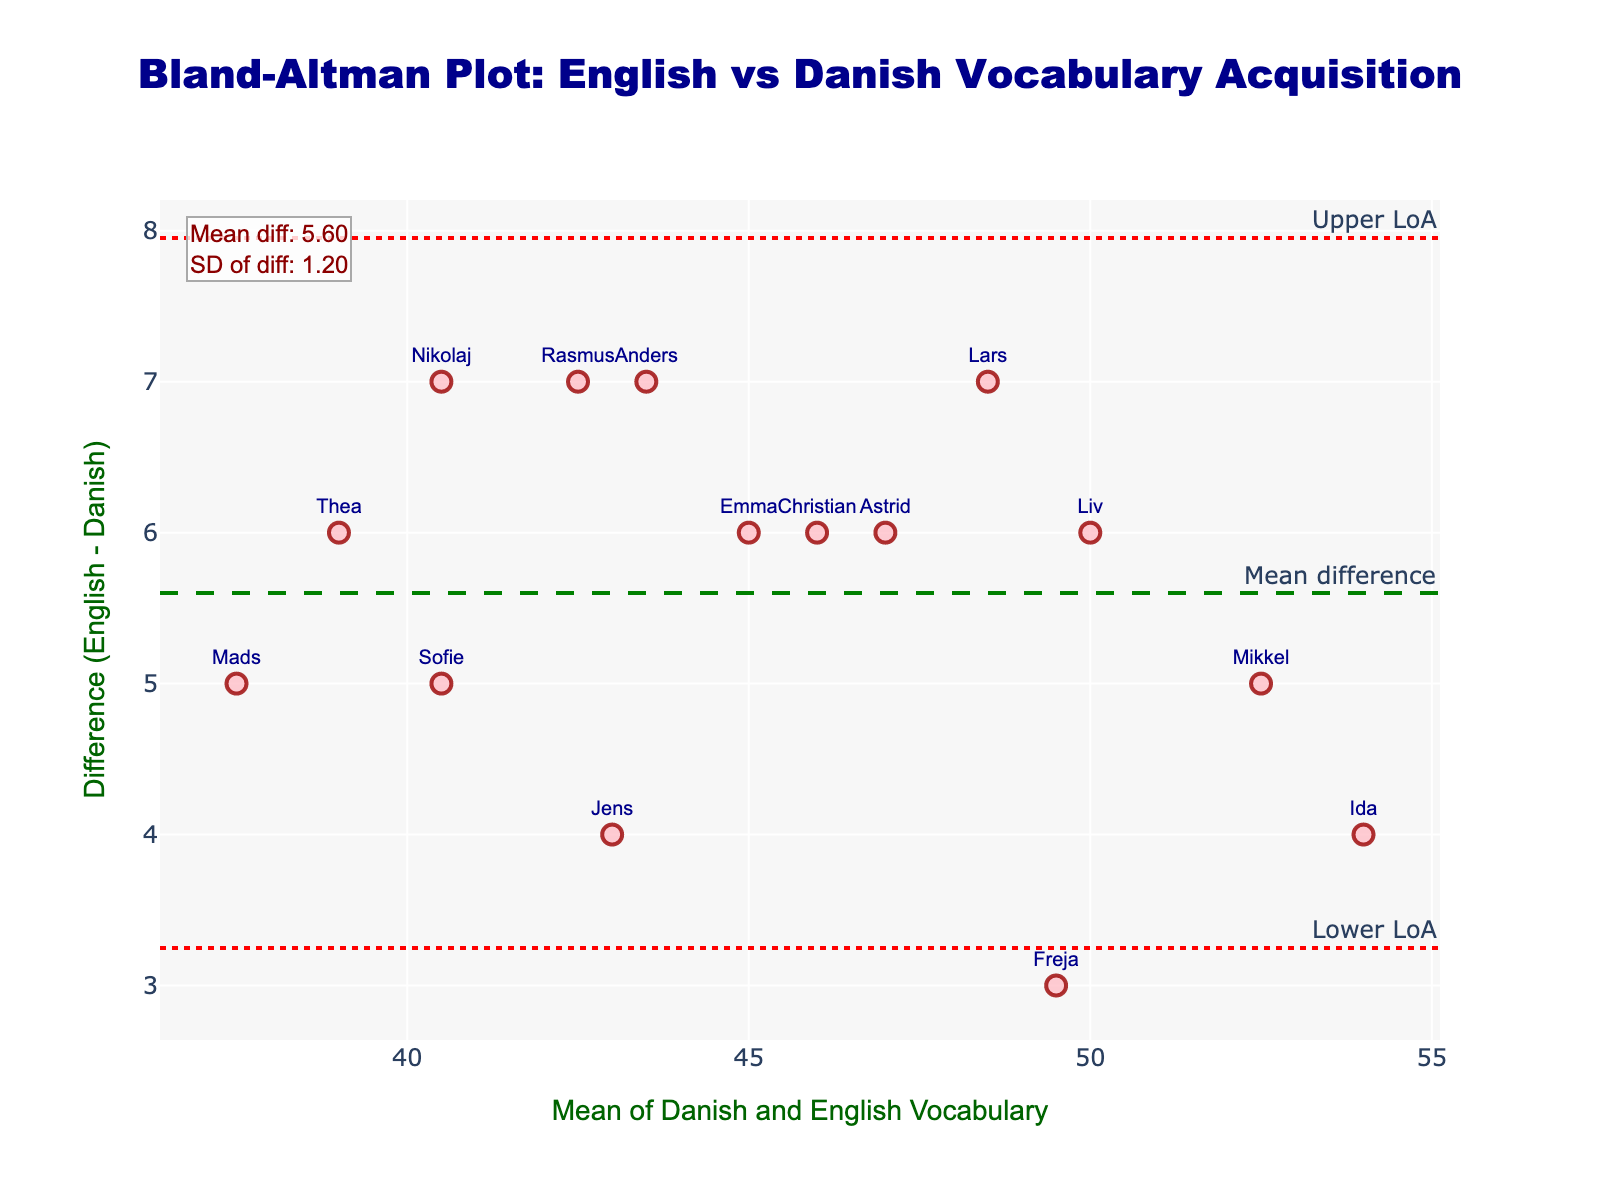What is the title of the plot? The title is displayed at the top center of the plot and reads "Bland-Altman Plot: English vs Danish Vocabulary Acquisition".
Answer: Bland-Altman Plot: English vs Danish Vocabulary Acquisition What are the axis titles? The x-axis is labeled "Mean of Danish and English Vocabulary", and the y-axis is labeled "Difference (English - Danish)".
Answer: Mean of Danish and English Vocabulary and Difference (English - Danish) How many data points are shown in the plot? Each subject has one data point, and there are 15 subjects listed in the data.
Answer: 15 What is the color of the data points on the plot? The data points are colored in a shade of pink.
Answer: pink What is the mean difference line value? The mean difference line is labeled, and the annotation indicates the mean difference value.
Answer: 5.73 What are the upper and lower limits of agreement (LoA)? The upper and lower LoA are represented by dotted lines, with labels indicating their values.
Answer: Upper LoA: 7.68, Lower LoA: 3.78 Which subject has the maximum difference between English and Danish vocabulary? From the labels on the plot, the subject with the highest difference is identified.
Answer: Lars How does the mean difference compare to the differences for Sofie and Mikkel? Sofie's difference is 5 and Mikkel's is also 5, both of which are less than the mean difference (5.73).
Answer: Less than 5.73 Are there more data points above or below the mean difference line? Observing the distribution of data points relative to the mean difference line indicates which side has more points.
Answer: Above What might indicate potential bias in vocabulary acquisition? If the data points are not symmetrically distributed around the mean difference line, it may indicate potential bias.
Answer: Asymmetric distribution 